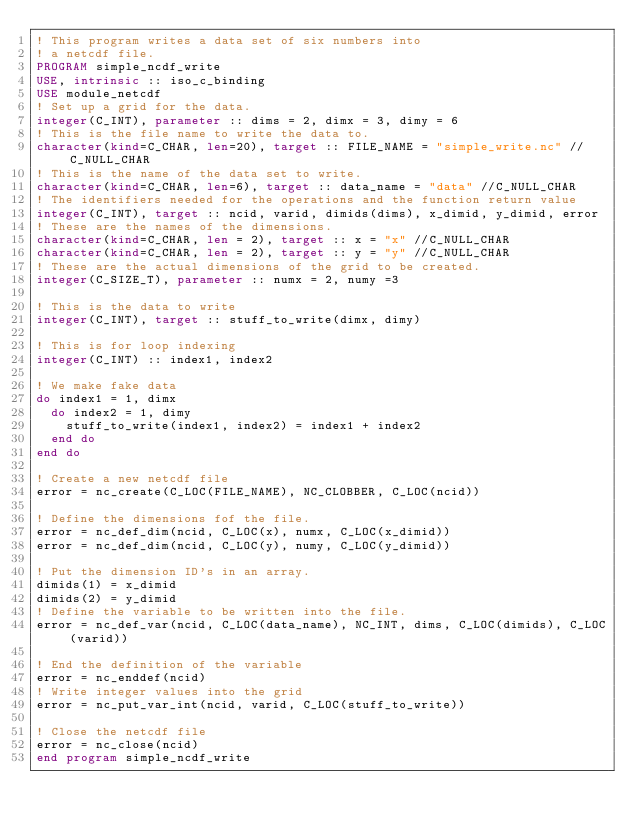<code> <loc_0><loc_0><loc_500><loc_500><_FORTRAN_>! This program writes a data set of six numbers into 
! a netcdf file.
PROGRAM simple_ncdf_write
USE, intrinsic :: iso_c_binding
USE module_netcdf
! Set up a grid for the data.
integer(C_INT), parameter :: dims = 2, dimx = 3, dimy = 6
! This is the file name to write the data to.
character(kind=C_CHAR, len=20), target :: FILE_NAME = "simple_write.nc" //C_NULL_CHAR
! This is the name of the data set to write.
character(kind=C_CHAR, len=6), target :: data_name = "data" //C_NULL_CHAR
! The identifiers needed for the operations and the function return value
integer(C_INT), target :: ncid, varid, dimids(dims), x_dimid, y_dimid, error
! These are the names of the dimensions.
character(kind=C_CHAR, len = 2), target :: x = "x" //C_NULL_CHAR
character(kind=C_CHAR, len = 2), target :: y = "y" //C_NULL_CHAR
! These are the actual dimensions of the grid to be created.
integer(C_SIZE_T), parameter :: numx = 2, numy =3

! This is the data to write
integer(C_INT), target :: stuff_to_write(dimx, dimy)

! This is for loop indexing
integer(C_INT) :: index1, index2

! We make fake data
do index1 = 1, dimx
  do index2 = 1, dimy
    stuff_to_write(index1, index2) = index1 + index2
  end do
end do

! Create a new netcdf file
error = nc_create(C_LOC(FILE_NAME), NC_CLOBBER, C_LOC(ncid))

! Define the dimensions fof the file.
error = nc_def_dim(ncid, C_LOC(x), numx, C_LOC(x_dimid))
error = nc_def_dim(ncid, C_LOC(y), numy, C_LOC(y_dimid))

! Put the dimension ID's in an array.
dimids(1) = x_dimid
dimids(2) = y_dimid
! Define the variable to be written into the file.
error = nc_def_var(ncid, C_LOC(data_name), NC_INT, dims, C_LOC(dimids), C_LOC(varid))

! End the definition of the variable
error = nc_enddef(ncid)
! Write integer values into the grid
error = nc_put_var_int(ncid, varid, C_LOC(stuff_to_write))

! Close the netcdf file
error = nc_close(ncid)
end program simple_ncdf_write
</code> 